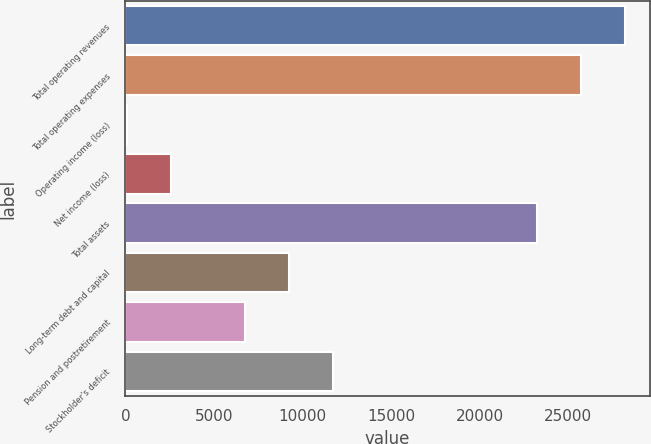<chart> <loc_0><loc_0><loc_500><loc_500><bar_chart><fcel>Total operating revenues<fcel>Total operating expenses<fcel>Operating income (loss)<fcel>Net income (loss)<fcel>Total assets<fcel>Long-term debt and capital<fcel>Pension and postretirement<fcel>Stockholder's deficit<nl><fcel>28212.6<fcel>25738.3<fcel>82<fcel>2556.3<fcel>23264<fcel>9254.3<fcel>6780<fcel>11728.6<nl></chart> 